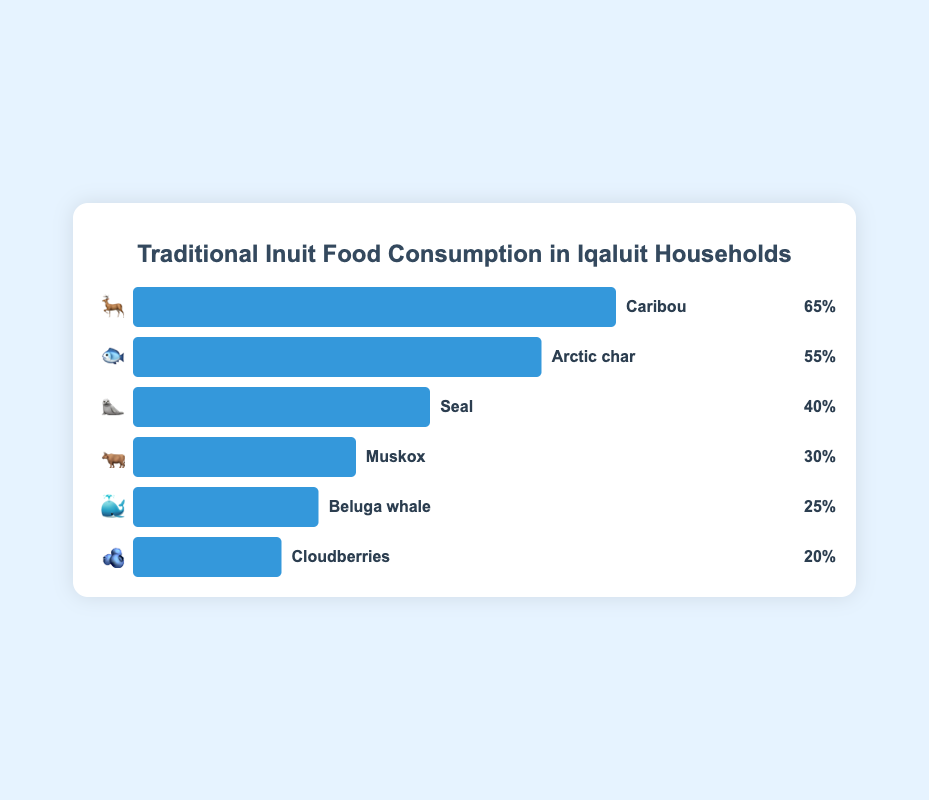What's the most consumed traditional Inuit food in Iqaluit households? The chart shows various traditional Inuit foods with their corresponding consumption percentages. Caribou has the highest percentage at 65%.
Answer: Caribou Which traditional Inuit food has a 55% consumption rate? In the chart, Arctic char has a consumption rate of 55%, as indicated next to its bar.
Answer: Arctic char Is seal consumption higher or lower than muskox consumption? According to the chart, seal has a consumption rate of 40%, while muskox has a rate of 30%, making seal consumption higher than muskox consumption.
Answer: Higher What is the combined percentage of consumption for Beluga whale and Cloudberries? Adding the consumption percentages of Beluga whale (25%) and Cloudberries (20%): 25% + 20% = 45%.
Answer: 45% How much lower is the percentage of Cloudberries compared to Caribou? By subtracting the consumption percentage of Cloudberries (20%) from Caribou (65%): 65% - 20% = 45%.
Answer: 45% Which traditional food has the lowest consumption rate and what is it? The chart shows that Cloudberries have the lowest consumption rate at 20%.
Answer: Cloudberries Arrange the foods in ascending order of their consumption rates. The chart provides consumption rates for each food. In ascending order: Cloudberries (20%), Beluga whale (25%), Muskox (30%), Seal (40%), Arctic char (55%), Caribou (65%).
Answer: Cloudberries, Beluga whale, Muskox, Seal, Arctic char, Caribou How many traditional Inuit foods have a consumption percentage above 50%? From the chart, Caribou (65%) and Arctic char (55%) are the only foods above 50%. There are 2 such foods.
Answer: 2 What's the difference in consumption rates between Arctic char and Seal? By subtracting the consumption rate of Seal (40%) from Arctic char (55%): 55% - 40% = 15%.
Answer: 15% Order the top three most consumed traditional Inuit foods. The chart indicates the top three foods by consumption rate are: 1. Caribou (65%), 2. Arctic char (55%), and 3. Seal (40%).
Answer: Caribou, Arctic char, Seal 